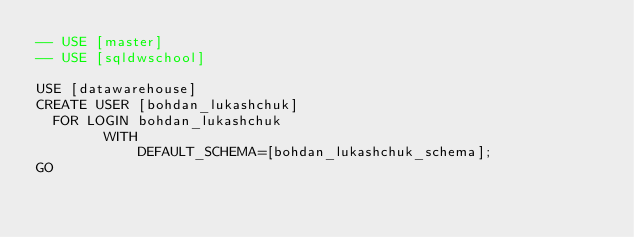<code> <loc_0><loc_0><loc_500><loc_500><_SQL_>-- USE [master]
-- USE [sqldwschool]

USE [datawarehouse]
CREATE USER [bohdan_lukashchuk]
	FOR LOGIN bohdan_lukashchuk
        WITH
            DEFAULT_SCHEMA=[bohdan_lukashchuk_schema];
GO</code> 